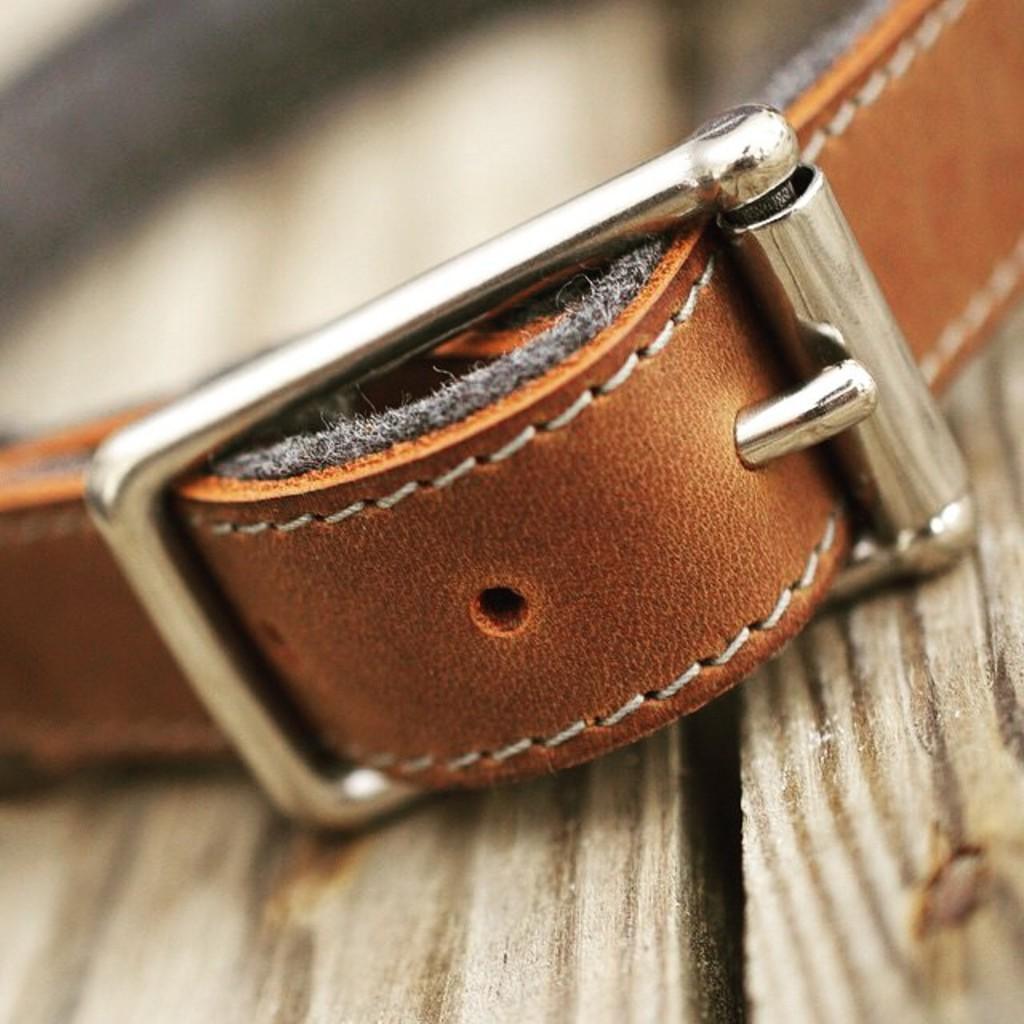Can you describe this image briefly? In this picture we can see a belt and blurry background. 